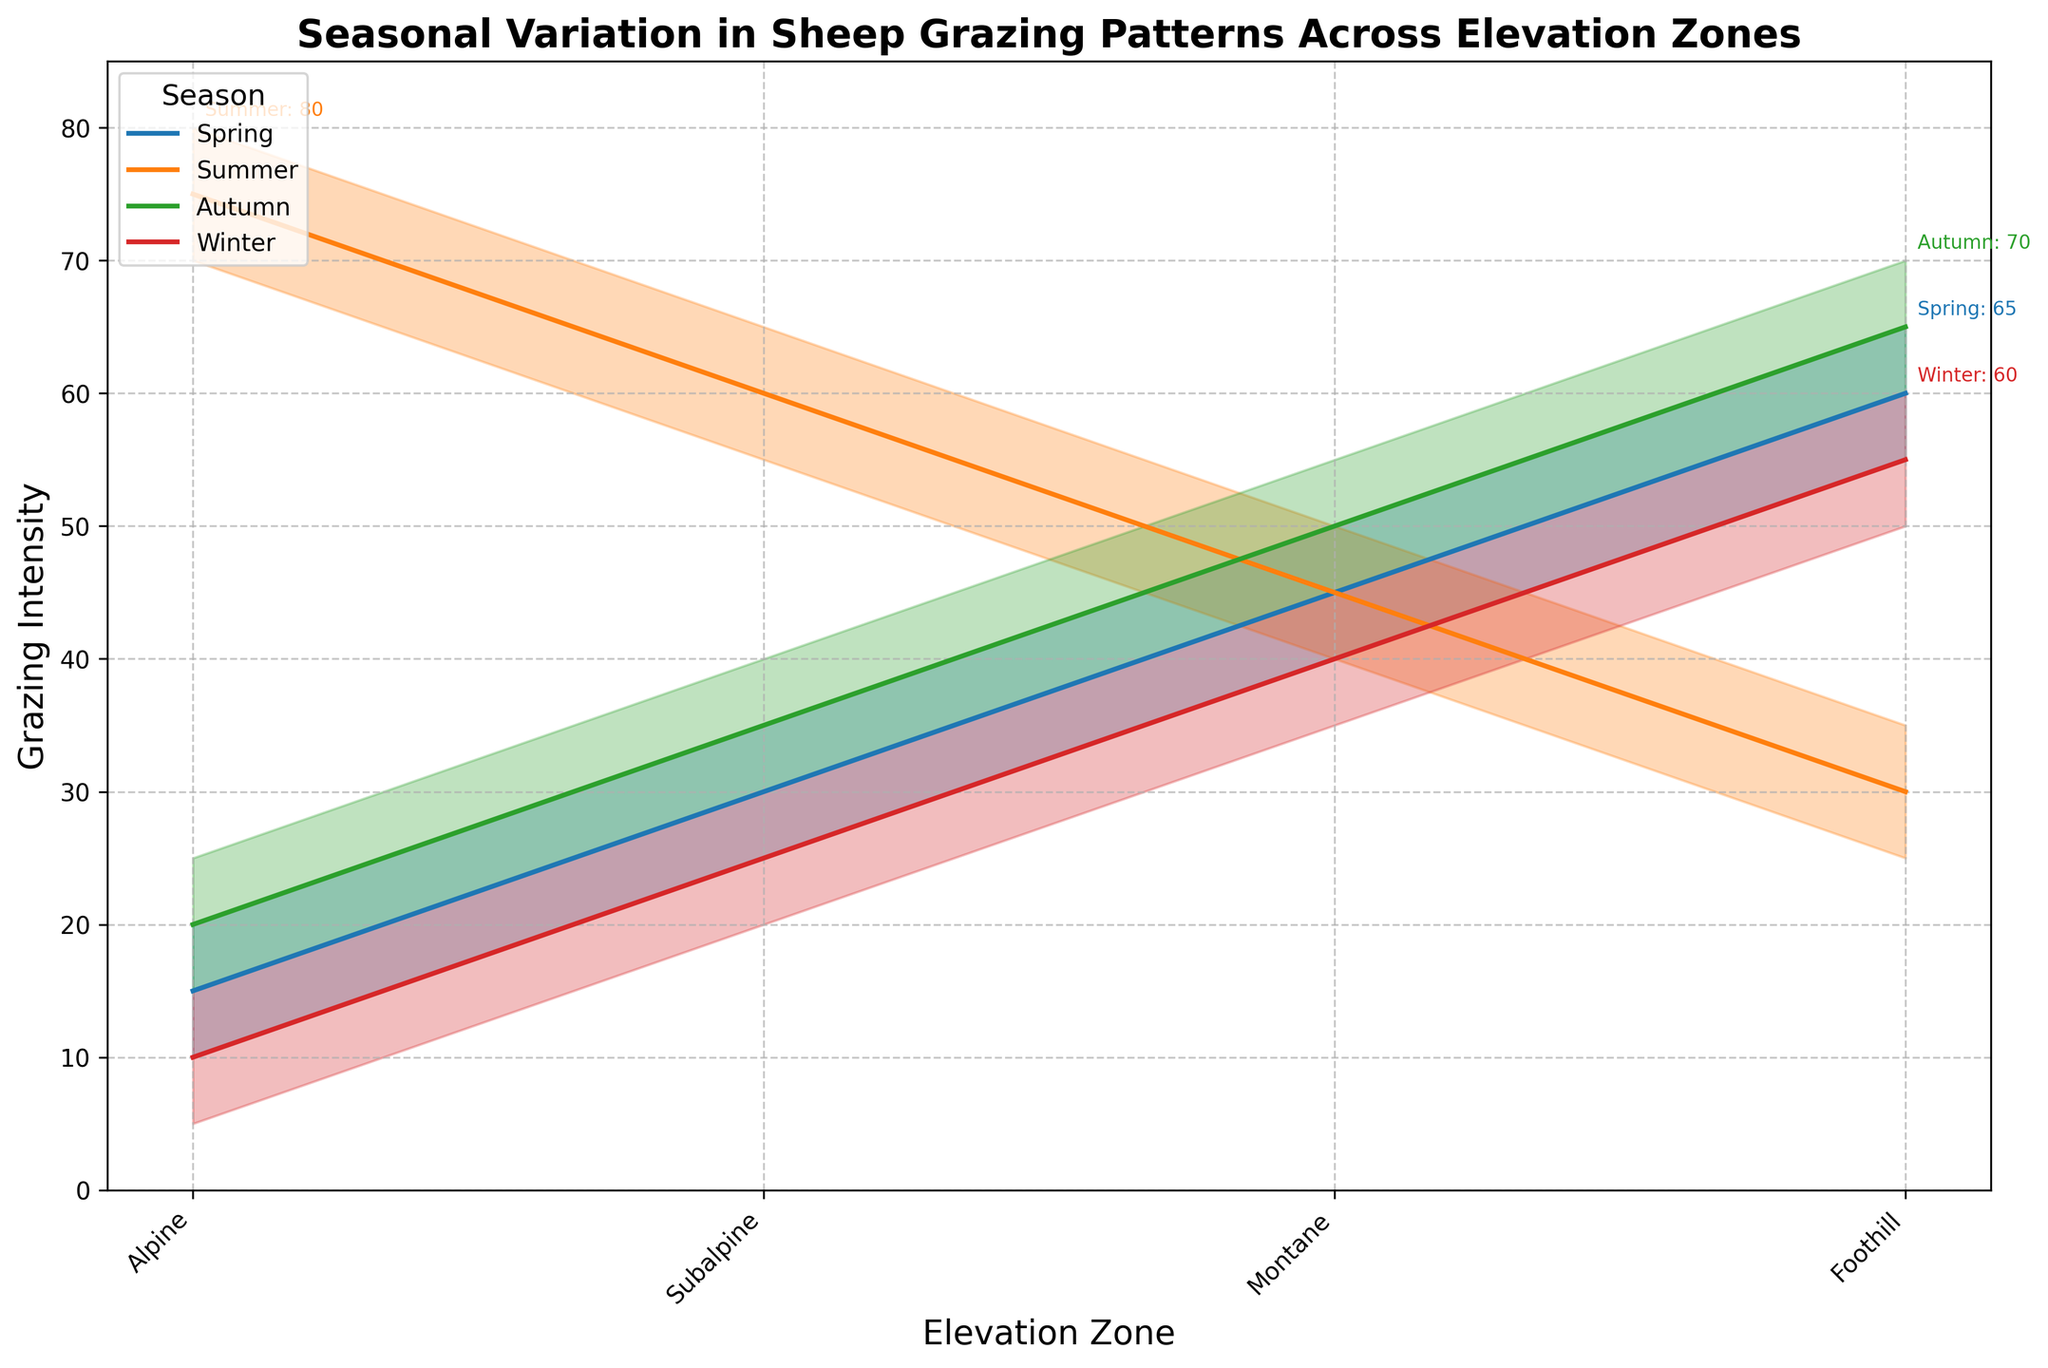What is the title of the chart? The chart's title is located at the top and generally summarises what the chart is about. Here, it states "Seasonal Variation in Sheep Grazing Patterns Across Elevation Zones," indicating the focus of the data presented.
Answer: Seasonal Variation in Sheep Grazing Patterns Across Elevation Zones Which season shows the highest median grazing intensity in Alpine zones? To find this, look at the Alpine zone section across different seasons and compare the median estimates represented by the middle line. Summer shows the highest median grazing intensity at Alpine zones with a value of 75.
Answer: Summer What's the difference in high estimates of grazing intensity between Summer and Winter in Foothill zones? Check the high estimates for Foothill zones in both Summer and Winter. In Summer, the high estimate is 35, and in Winter, it's 60. The difference is calculated as 60 - 35.
Answer: 25 How does the grazing intensity in Subalpine zones compare between Spring and Autumn? Look at the Subalpine zones for both Spring and Autumn and compare the median estimates. In Spring, the median estimate is 30, and in Autumn, it is 35. Autumn has a slightly higher value.
Answer: Autumn has higher grazing intensity Which elevation zone shows the least variation in grazing intensity during Spring? Look at the range (high estimate minus low estimate) for each elevation zone in Spring. The smallest range indicates the least variation. For Alpine, it's 20 - 10 = 10; Subalpine, 35 - 25 = 10; Montane, 50 - 40 = 10; Foothill, 65 - 55 = 10. All zones show equal variation.
Answer: All zones show equal variation What's the grazing intensity range for Montane zones in Summer? The range is calculated by subtracting the low estimate from the high estimate for Montane zones in Summer. It's 50 - 40.
Answer: 10 Which season has the most uniform grazing pattern across all elevation zones? To answer this, compare the grazing patterns (median estimates) for each elevation zone across different seasons. Winter shows the least variation (uniformity) across elevation zones with similar grazing intensity values (10, 25, 40, 55).
Answer: Winter In which season and elevation zone does the grazing intensity reach its highest high estimate? Check all seasons and elevation zones to find the highest value in the high estimate column. Summer Foothill shows the highest high estimate at 80.
Answer: Summer Foothill Compare the median grazing intensity in Montane zones during Winter and Autumn. Find the median estimates for Montane zones in both Winter and Autumn. In Winter, it's 40, while in Autumn, it's 50.
Answer: Autumn has higher median intensity What is the median grazing intensity for Foothill zones in Autumn? Look at the median estimate for Foothill zones specifically in the Autumn season. The median estimate is given as 65.
Answer: 65 